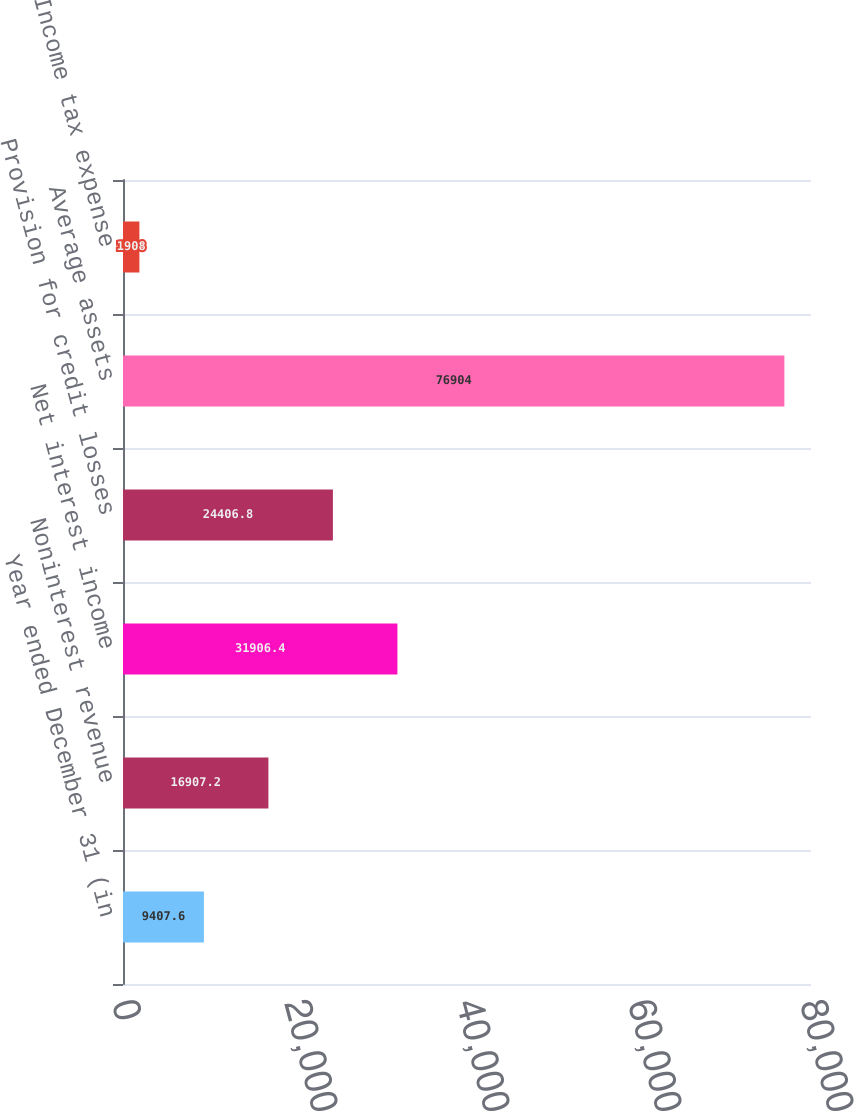<chart> <loc_0><loc_0><loc_500><loc_500><bar_chart><fcel>Year ended December 31 (in<fcel>Noninterest revenue<fcel>Net interest income<fcel>Provision for credit losses<fcel>Average assets<fcel>Income tax expense<nl><fcel>9407.6<fcel>16907.2<fcel>31906.4<fcel>24406.8<fcel>76904<fcel>1908<nl></chart> 